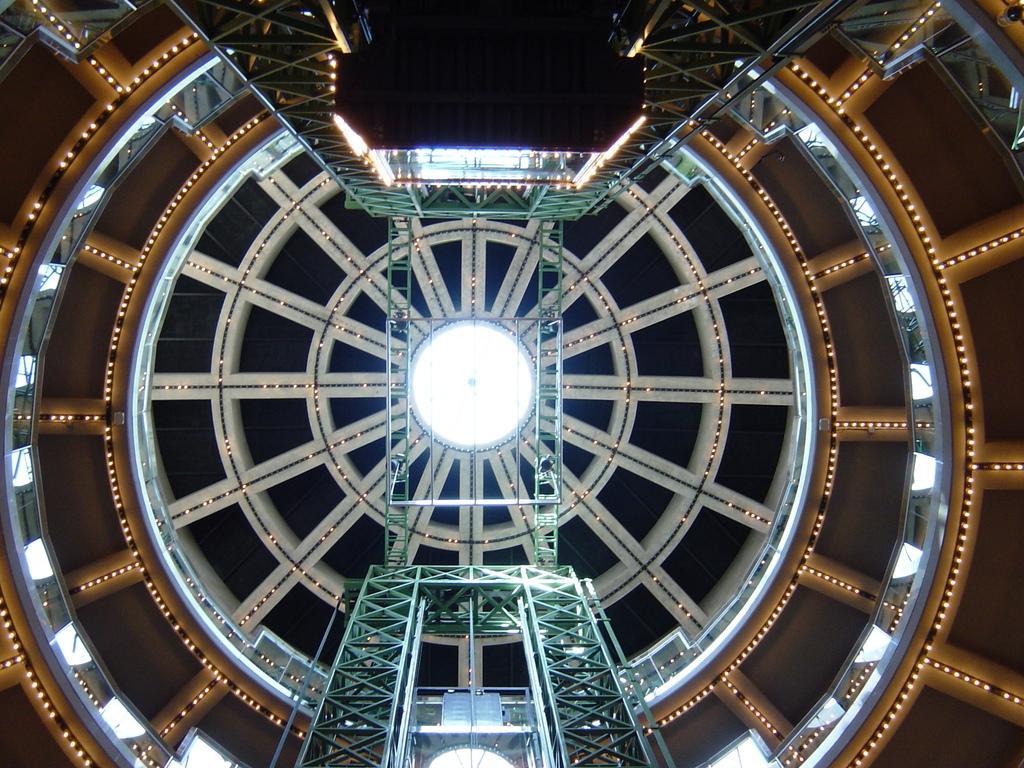Describe this image in one or two sentences. The picture is taken inside the building. In the center of the picture there is iron frame and there is connecting iron frame like a bridge. In the center of the picture there is a dome. In this picture there are lights. 